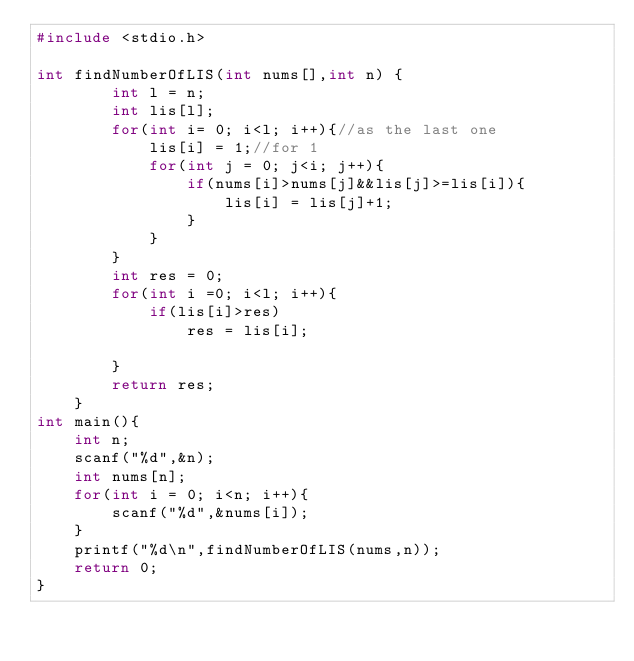<code> <loc_0><loc_0><loc_500><loc_500><_C++_>#include <stdio.h>

int findNumberOfLIS(int nums[],int n) {
        int l = n;
        int lis[l];
        for(int i= 0; i<l; i++){//as the last one
            lis[i] = 1;//for 1
            for(int j = 0; j<i; j++){
                if(nums[i]>nums[j]&&lis[j]>=lis[i]){
                    lis[i] = lis[j]+1; 
                }
            }   
        }
        int res = 0;
        for(int i =0; i<l; i++){
            if(lis[i]>res)
                res = lis[i];
            
        }
        return res;  
    }
int main(){
	int n;
	scanf("%d",&n);
	int nums[n];
	for(int i = 0; i<n; i++){
		scanf("%d",&nums[i]);
	}
	printf("%d\n",findNumberOfLIS(nums,n));
	return 0;
}
</code> 